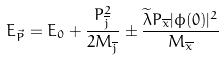Convert formula to latex. <formula><loc_0><loc_0><loc_500><loc_500>E _ { \vec { P } } = E _ { 0 } + \frac { P _ { \overline { j } } ^ { 2 } } { 2 M _ { \overline { j } } } \pm \frac { \widetilde { \lambda } P _ { \overline { x } } | \phi ( 0 ) | ^ { 2 } } { M _ { \overline { x } } }</formula> 